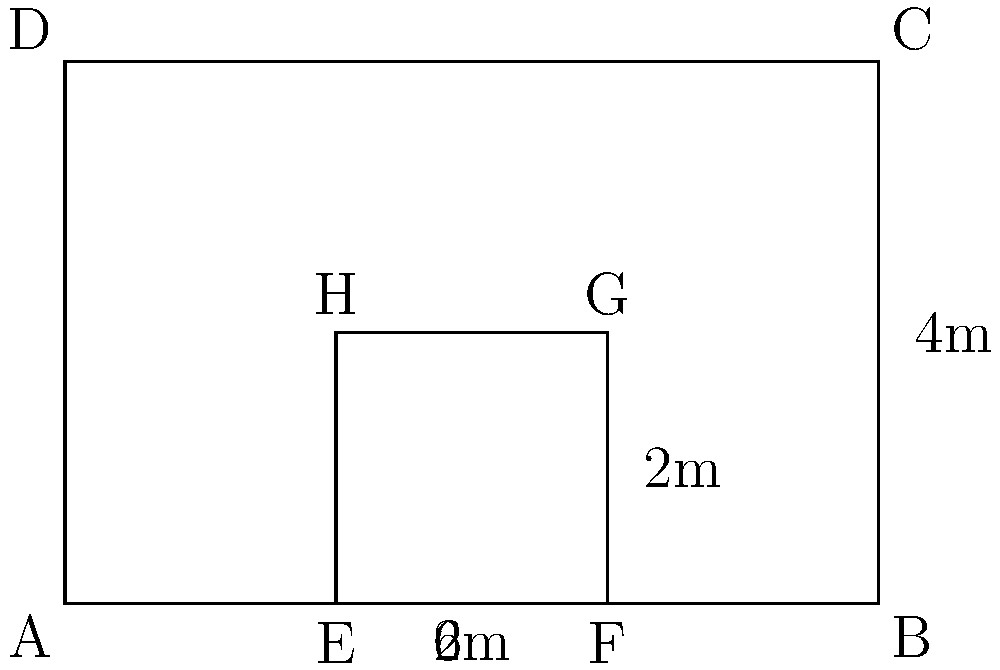In a conflict zone, a rectangular protective barrier is being designed to shield a group of reporters. The outer dimensions of the barrier are 6m x 4m. An inner reinforced area is planned with dimensions 2m x 2m, as shown in the diagram. If the effectiveness of protection is proportional to the area covered, what percentage increase in protection does the inner reinforced area provide compared to the outer barrier alone? To solve this problem, we need to follow these steps:

1. Calculate the area of the outer barrier:
   $$A_{outer} = 6m \times 4m = 24m^2$$

2. Calculate the area of the inner reinforced section:
   $$A_{inner} = 2m \times 2m = 4m^2$$

3. The effective protection area is the sum of both areas:
   $$A_{total} = A_{outer} + A_{inner} = 24m^2 + 4m^2 = 28m^2$$

4. Calculate the percentage increase in protection:
   $$\text{Percentage increase} = \frac{A_{total} - A_{outer}}{A_{outer}} \times 100\%$$
   $$= \frac{28m^2 - 24m^2}{24m^2} \times 100\%$$
   $$= \frac{4m^2}{24m^2} \times 100\%$$
   $$= \frac{1}{6} \times 100\% = 16.67\%$$

Therefore, the inner reinforced area provides a 16.67% increase in protection compared to the outer barrier alone.
Answer: 16.67% 